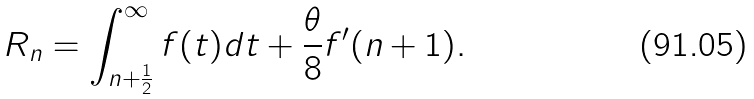<formula> <loc_0><loc_0><loc_500><loc_500>R _ { n } = \int _ { n + \frac { 1 } { 2 } } ^ { \infty } f ( t ) d t + \frac { \theta } { 8 } f ^ { \prime } ( n + 1 ) .</formula> 